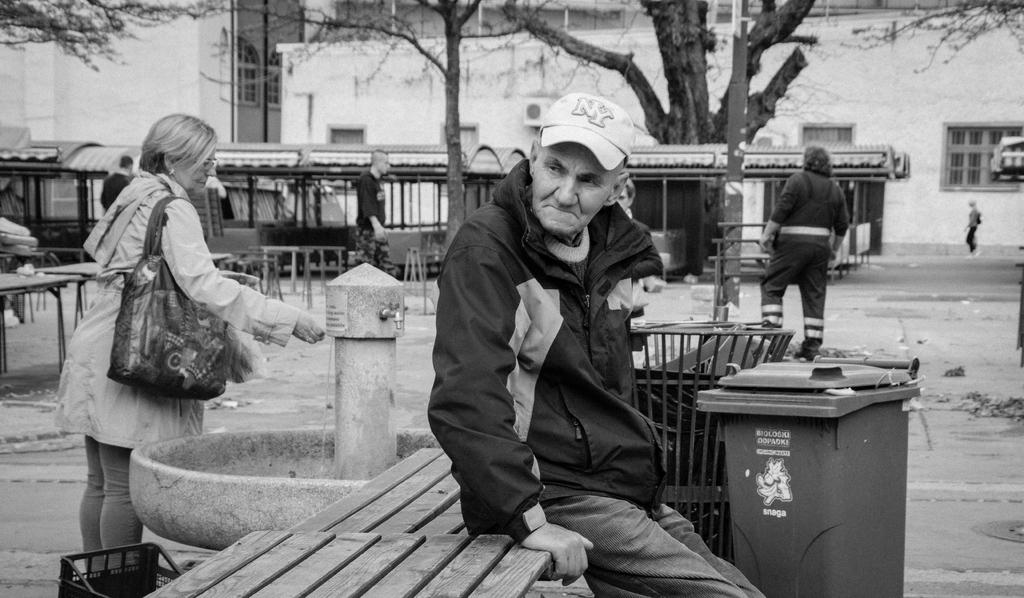<image>
Relay a brief, clear account of the picture shown. Man sitting in front of a garbage can which says "Snaga" on it. 